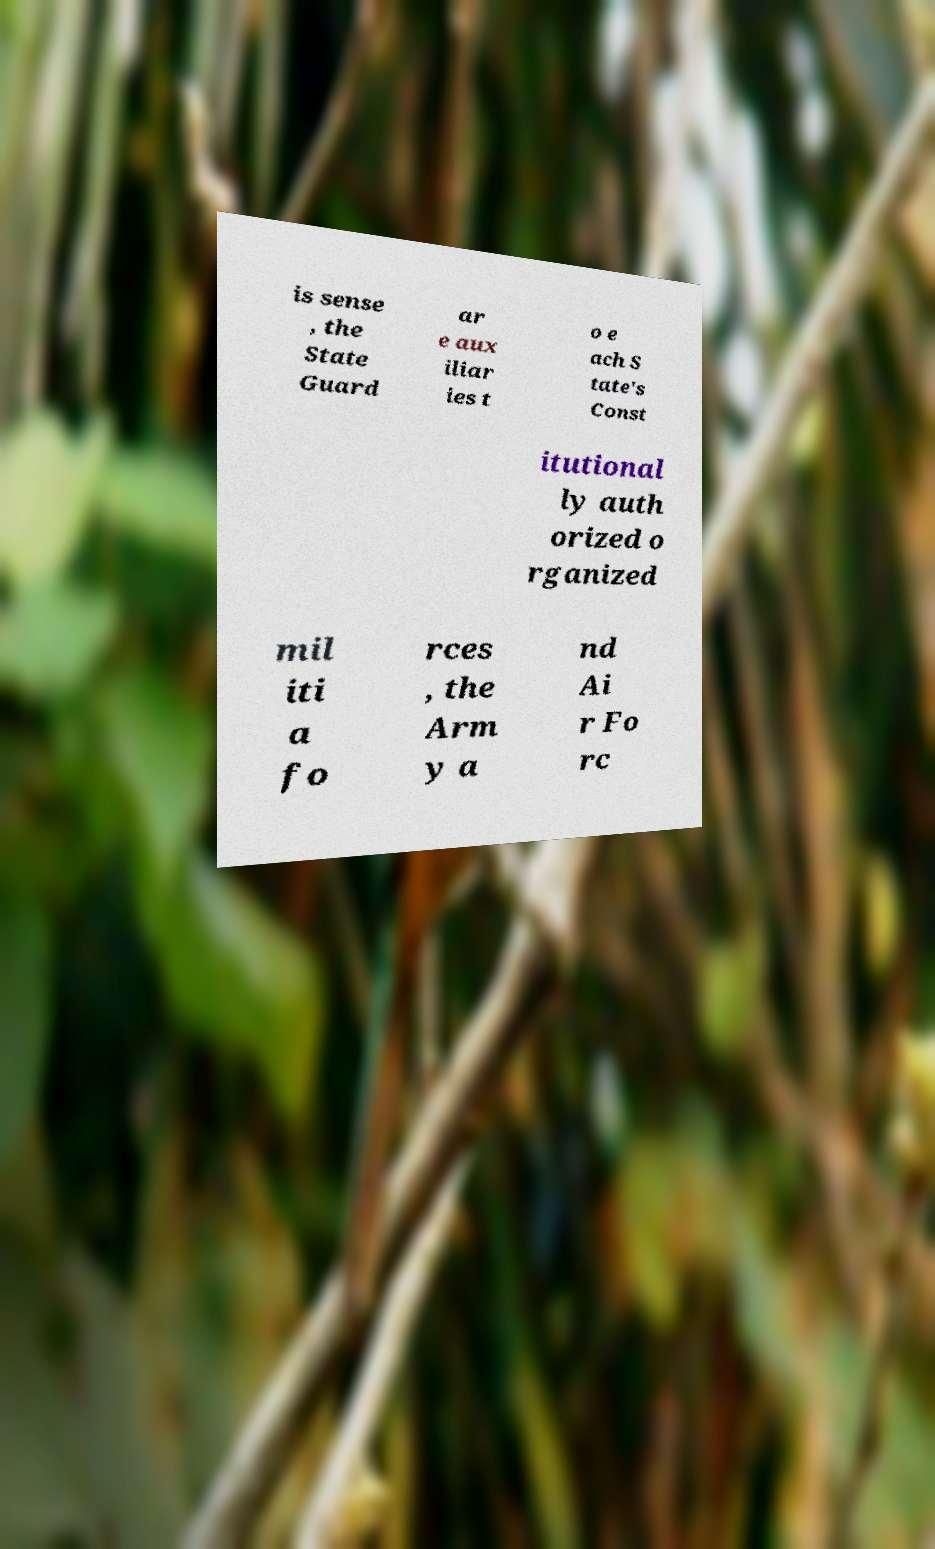What messages or text are displayed in this image? I need them in a readable, typed format. is sense , the State Guard ar e aux iliar ies t o e ach S tate's Const itutional ly auth orized o rganized mil iti a fo rces , the Arm y a nd Ai r Fo rc 